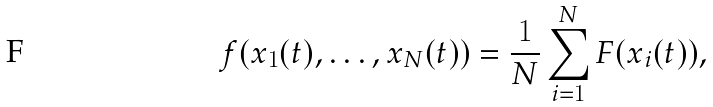Convert formula to latex. <formula><loc_0><loc_0><loc_500><loc_500>f ( x _ { 1 } ( t ) , \dots , x _ { N } ( t ) ) = \frac { 1 } { N } \sum _ { i = 1 } ^ { N } F ( x _ { i } ( t ) ) ,</formula> 